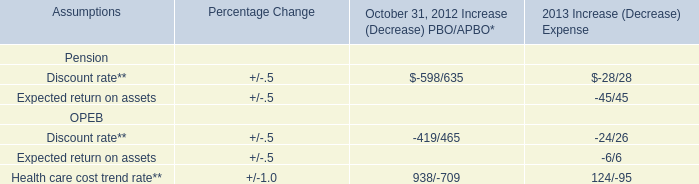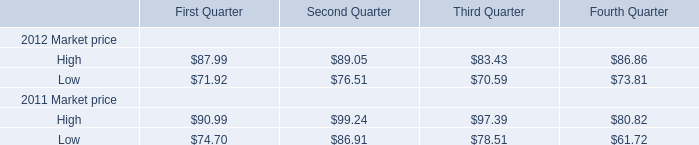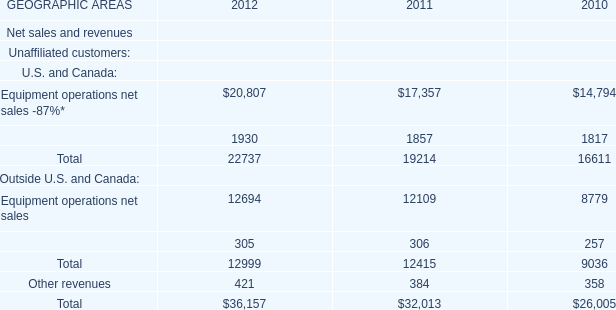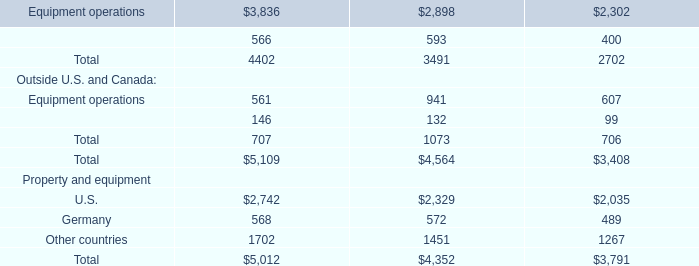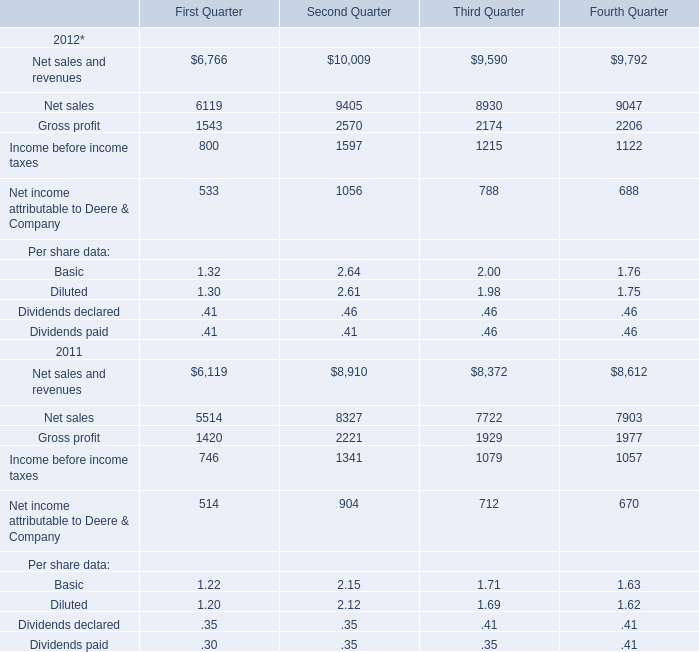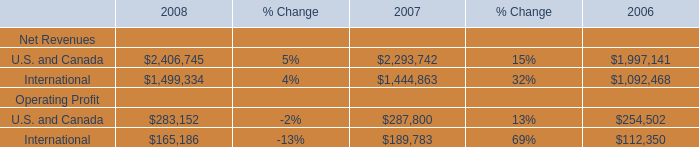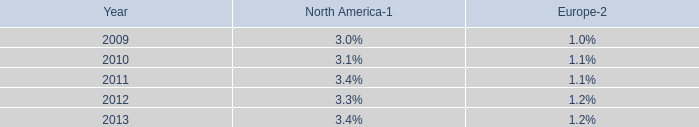How long does Equipment operations net sales keep growing? (in year) 
Computations: (2012 - 2010)
Answer: 2.0. 